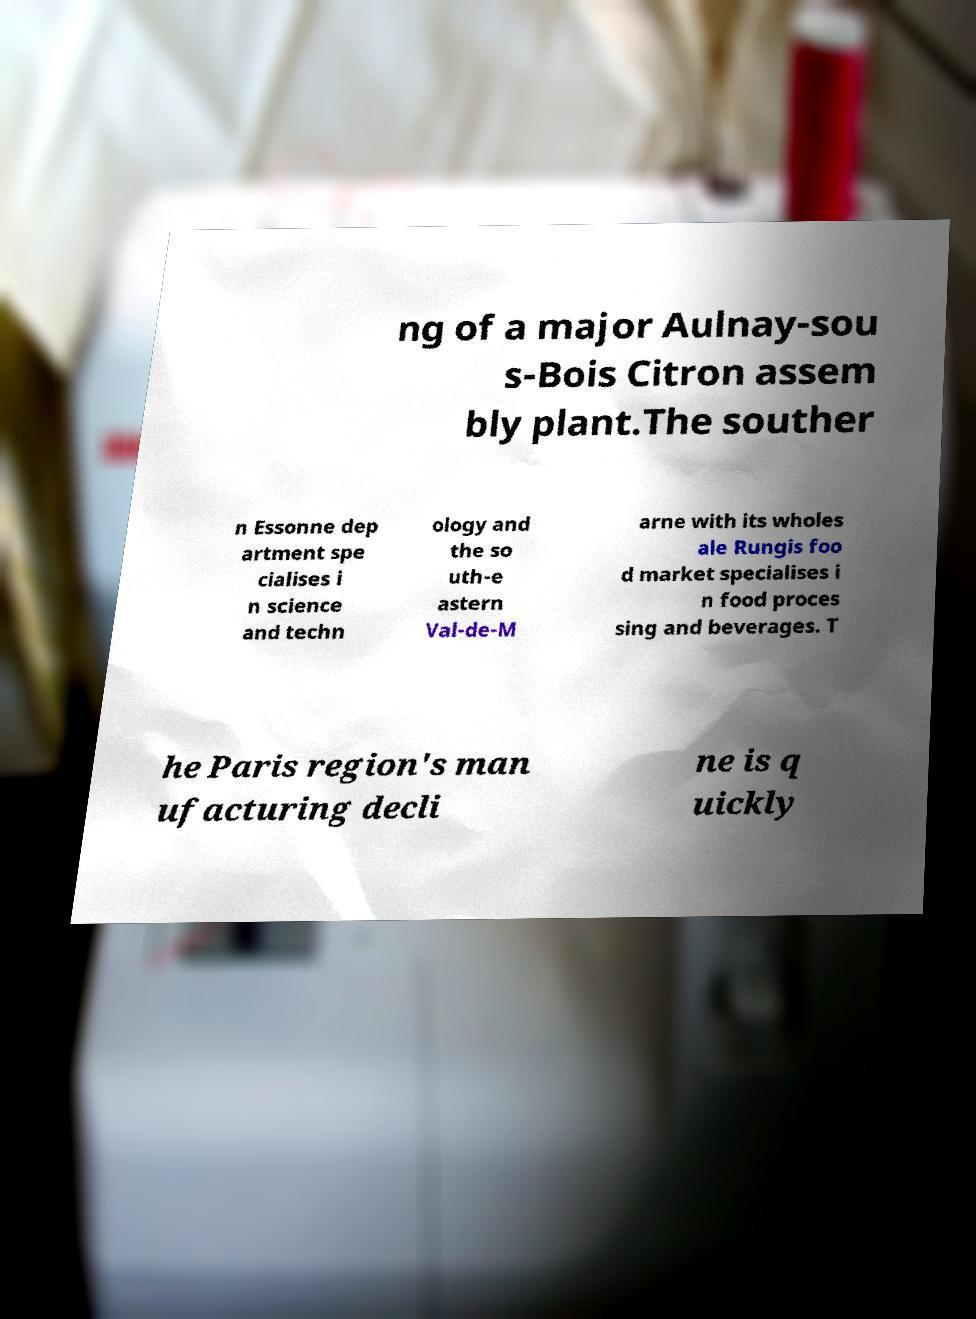There's text embedded in this image that I need extracted. Can you transcribe it verbatim? ng of a major Aulnay-sou s-Bois Citron assem bly plant.The souther n Essonne dep artment spe cialises i n science and techn ology and the so uth-e astern Val-de-M arne with its wholes ale Rungis foo d market specialises i n food proces sing and beverages. T he Paris region's man ufacturing decli ne is q uickly 